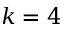<formula> <loc_0><loc_0><loc_500><loc_500>k = 4</formula> 